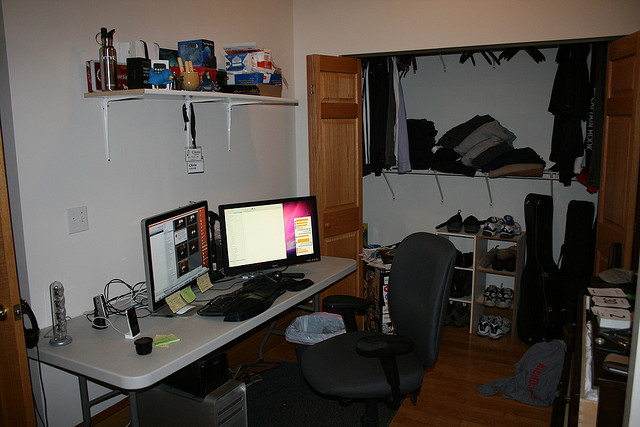<image>Is there a light on outside? It is unknown if there is a light on outside. What electronic is on the shelf above the computer? There is no electronic on the shelf above the computer. However, it can be a monitor, a camera, a phone, a radio, speakers or a webcam. Is there a light on outside? I don't know if there is a light on outside. It seems like there is no light on outside. What electronic is on the shelf above the computer? I am not sure what electronic is on the shelf above the computer. It can be seen 'monitor', 'camera', 'phone', 'radio', 'speakers', or 'webcam'. 